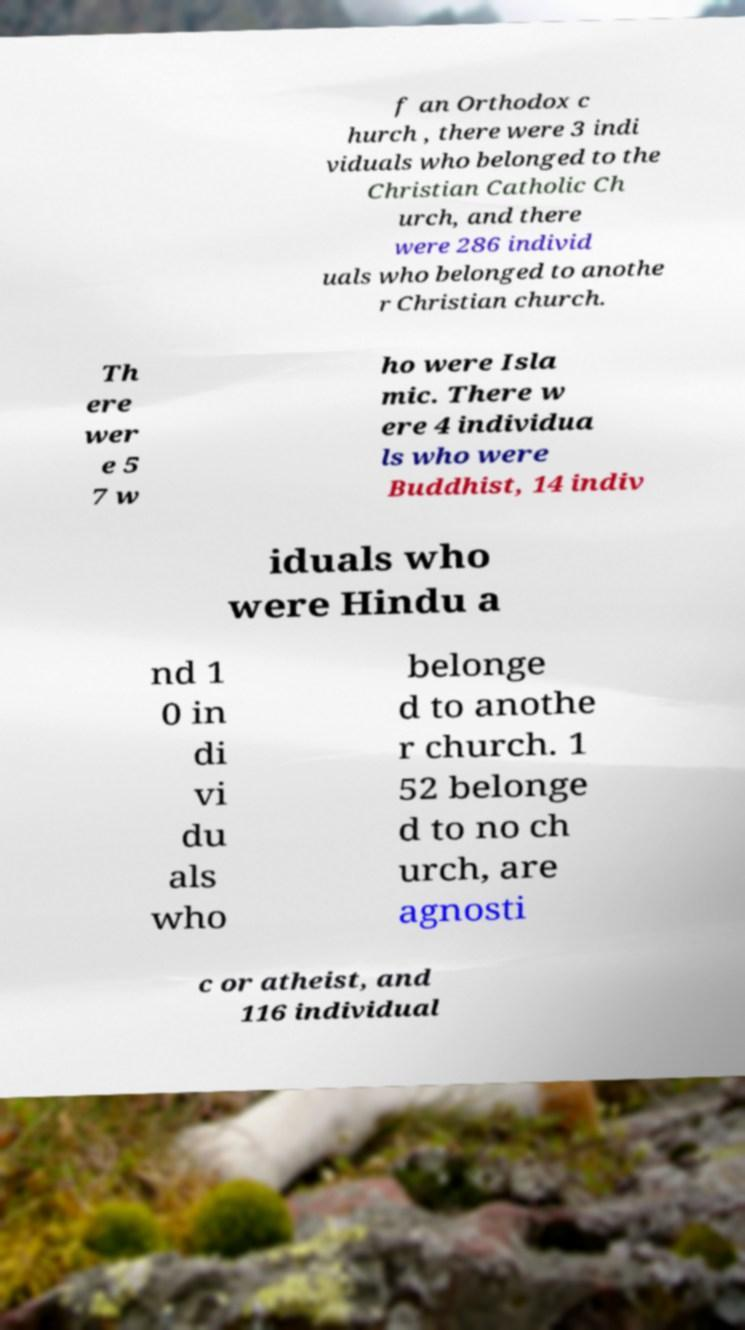Can you accurately transcribe the text from the provided image for me? f an Orthodox c hurch , there were 3 indi viduals who belonged to the Christian Catholic Ch urch, and there were 286 individ uals who belonged to anothe r Christian church. Th ere wer e 5 7 w ho were Isla mic. There w ere 4 individua ls who were Buddhist, 14 indiv iduals who were Hindu a nd 1 0 in di vi du als who belonge d to anothe r church. 1 52 belonge d to no ch urch, are agnosti c or atheist, and 116 individual 